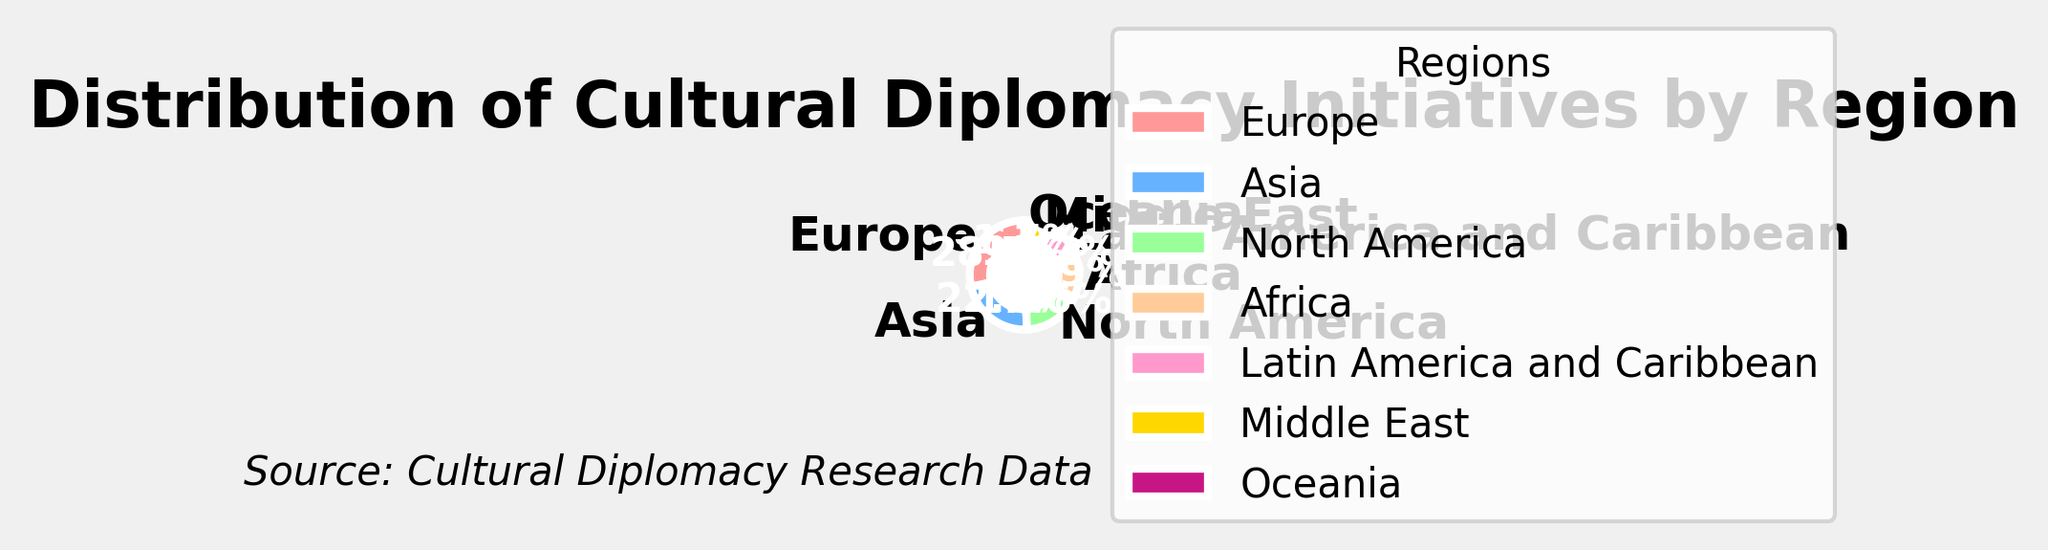Which region has the highest percentage of cultural diplomacy initiatives? By looking at the chart, the largest slice of the pie belongs to Europe, which has a percentage value of 28.5%.
Answer: Europe Which has a higher percentage: Asia or North America? Asia has 22.3% and North America has 17.6%. Since 22.3% is greater than 17.6%, Asia has a higher percentage.
Answer: Asia What is the sum of the percentages for Africa, Latin America and the Caribbean, and Oceania? Adding the percentage values for Africa (12.9%), Latin America and the Caribbean (10.2%), and Oceania (1.7%): 12.9 + 10.2 + 1.7 = 24.8%.
Answer: 24.8% Compare the percentages of the Middle East and Oceania. How many times greater is the percentage of the Middle East? The percentage of the Middle East is 6.8% and Oceania is 1.7%. Dividing 6.8 by 1.7 gives 4, so the Middle East has a percentage that is 4 times greater than Oceania.
Answer: 4 times Which regions collectively account for more than 50% of the initiatives? Adding the percentages of Europe (28.5%), Asia (22.3%), and North America (17.6%): 28.5 + 22.3 + 17.6 = 68.4%. Since 68.4% is more than 50%, these three regions collectively account for more than half of the initiatives.
Answer: Europe, Asia, North America What is the percentage difference between Europe and Asia? Subtracting Asia's percentage (22.3%) from Europe's percentage (28.5%): 28.5 - 22.3 = 6.2%.
Answer: 6.2% If you combine the percentages of Asia and North America, is their sum greater than Europe's percentage? Adding Asia (22.3%) and North America (17.6%): 22.3 + 17.6 = 39.9%. Comparing this sum to Europe (28.5%), 39.9% is indeed greater than 28.5%.
Answer: Yes Which two regions have the lowest percentages of cultural diplomacy initiatives? The smallest slices in the pie chart belong to the Middle East (6.8%) and Oceania (1.7%).
Answer: Middle East, Oceania What is the combined percentage of Europe, Asia, and Africa? Adding the percentages for Europe (28.5%), Asia (22.3%), and Africa (12.9%): 28.5 + 22.3 + 12.9 = 63.7%.
Answer: 63.7% Among the listed regions, which region's pie slice is colored red? By looking at the visual attributes of the pie chart, the slice representing North America is colored red.
Answer: North America 